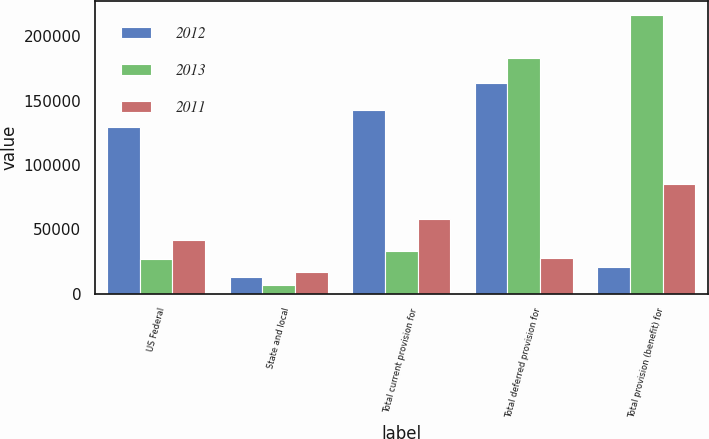Convert chart. <chart><loc_0><loc_0><loc_500><loc_500><stacked_bar_chart><ecel><fcel>US Federal<fcel>State and local<fcel>Total current provision for<fcel>Total deferred provision for<fcel>Total provision (benefit) for<nl><fcel>2012<fcel>129633<fcel>12649<fcel>142599<fcel>163550<fcel>20951<nl><fcel>2013<fcel>27100<fcel>6437<fcel>33537<fcel>183202<fcel>216739<nl><fcel>2011<fcel>41452<fcel>16678<fcel>58130<fcel>27347<fcel>85477<nl></chart> 